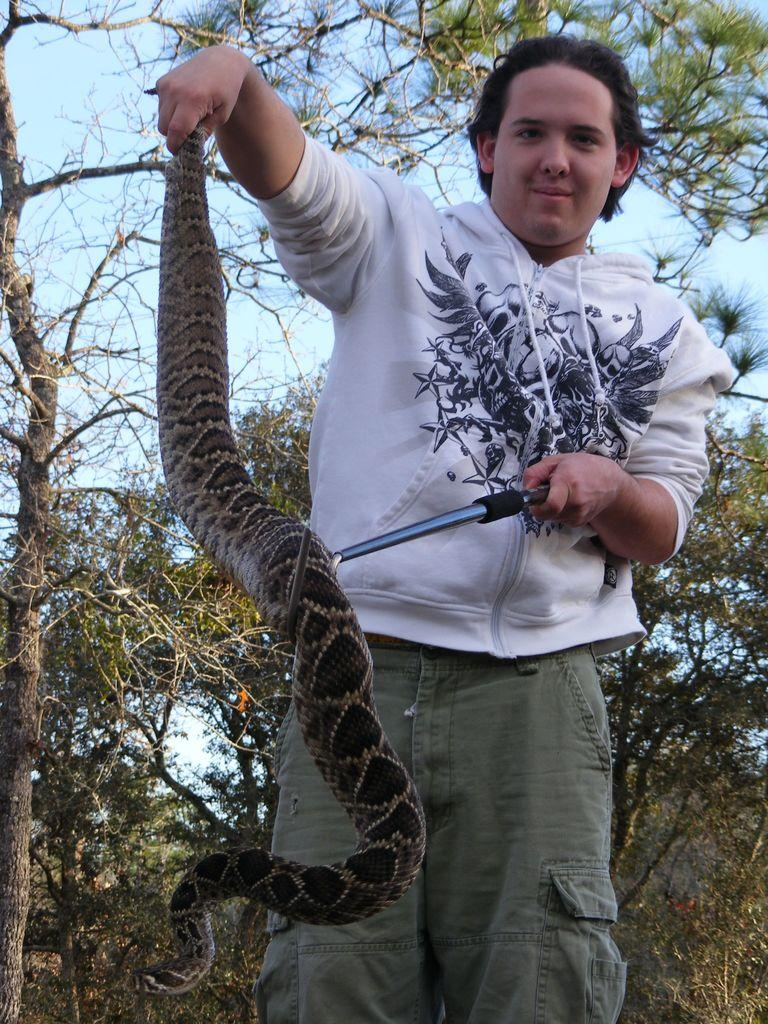Who is the main subject in the image? There is a boy in the image. Where is the boy positioned in the image? The boy is standing on the right side of the image. What is the boy holding in his hands? The boy is holding a snake in his hands. What can be seen in the background of the image? There are trees in the background of the image. What type of health advice can be seen in the image? There is no health advice present in the image; it features a boy holding a snake. Can you tell me how the snake is connected to the cord in the image? There is no cord present in the image, and the snake is not connected to any object. 